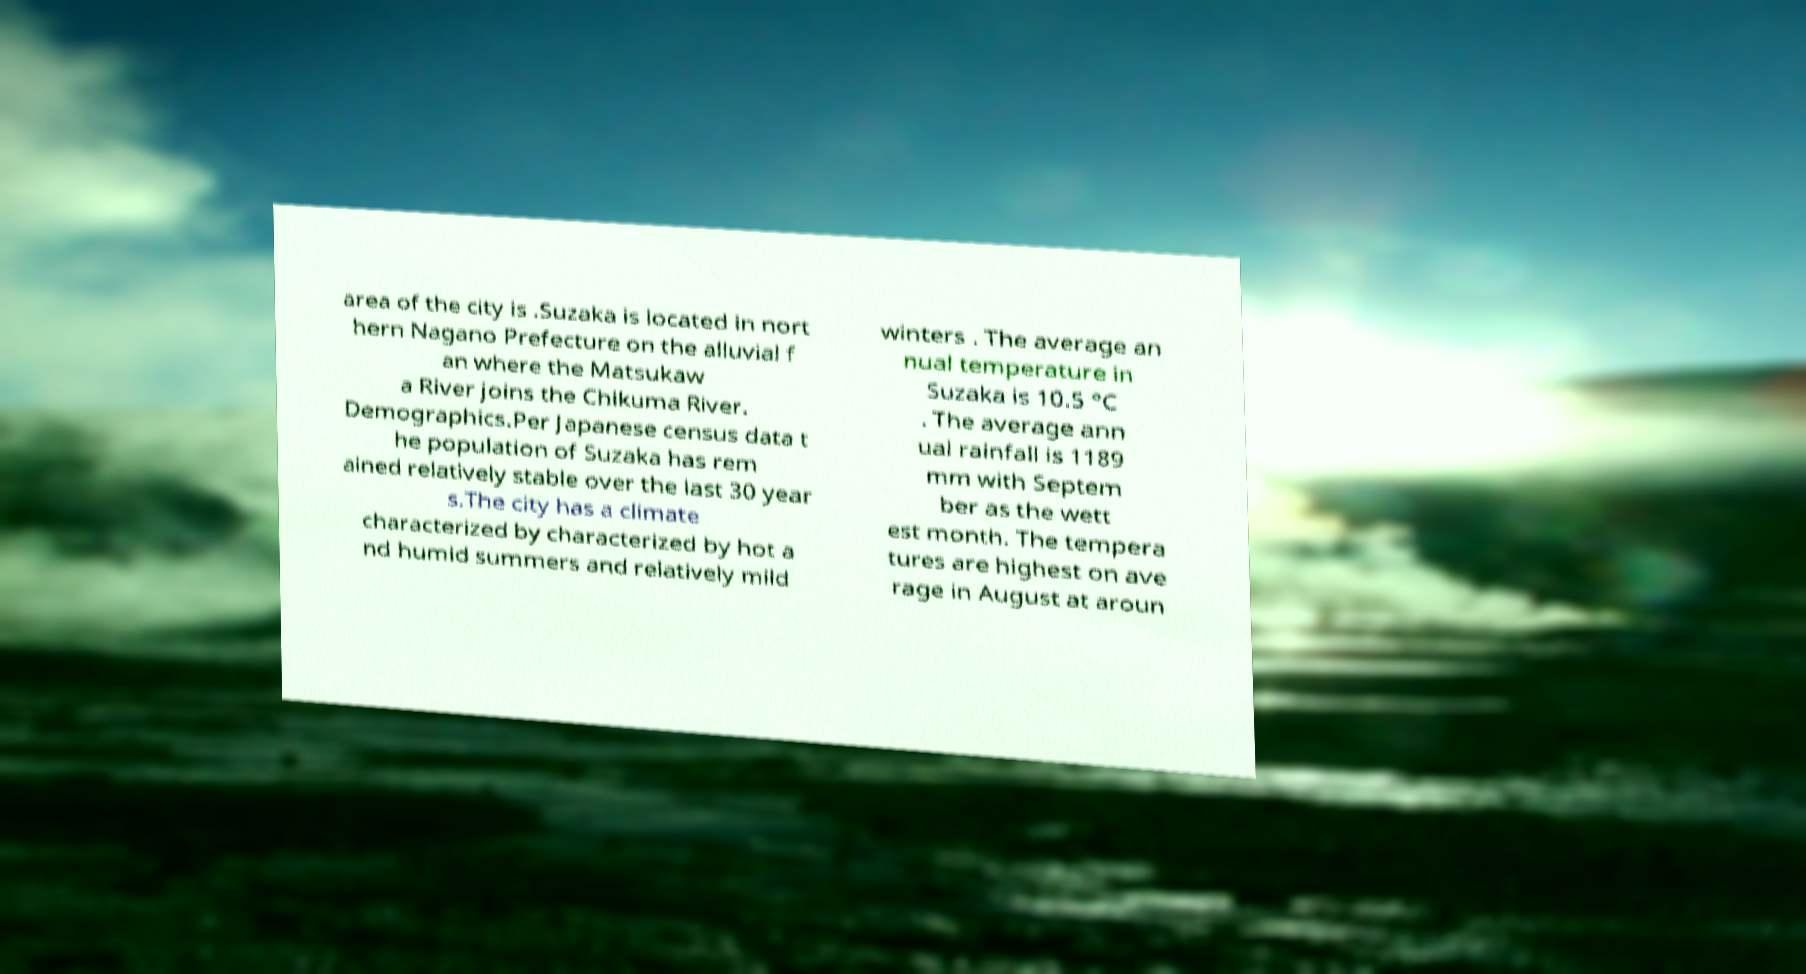Can you accurately transcribe the text from the provided image for me? area of the city is .Suzaka is located in nort hern Nagano Prefecture on the alluvial f an where the Matsukaw a River joins the Chikuma River. Demographics.Per Japanese census data t he population of Suzaka has rem ained relatively stable over the last 30 year s.The city has a climate characterized by characterized by hot a nd humid summers and relatively mild winters . The average an nual temperature in Suzaka is 10.5 °C . The average ann ual rainfall is 1189 mm with Septem ber as the wett est month. The tempera tures are highest on ave rage in August at aroun 